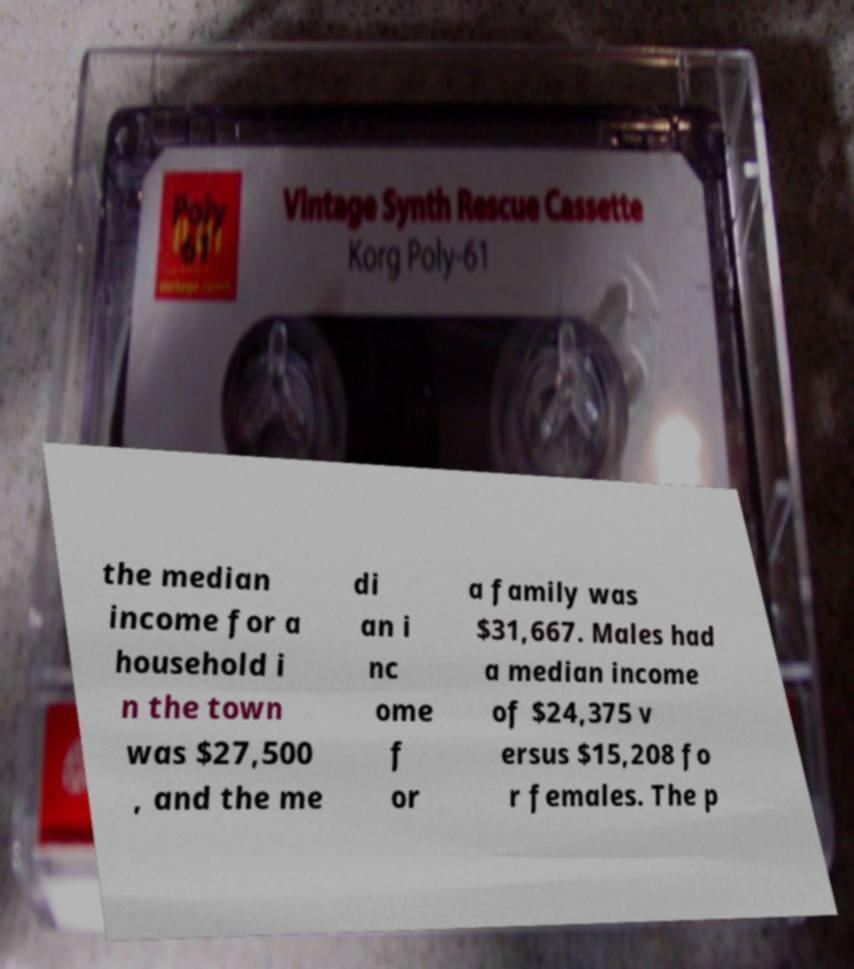Can you read and provide the text displayed in the image?This photo seems to have some interesting text. Can you extract and type it out for me? the median income for a household i n the town was $27,500 , and the me di an i nc ome f or a family was $31,667. Males had a median income of $24,375 v ersus $15,208 fo r females. The p 